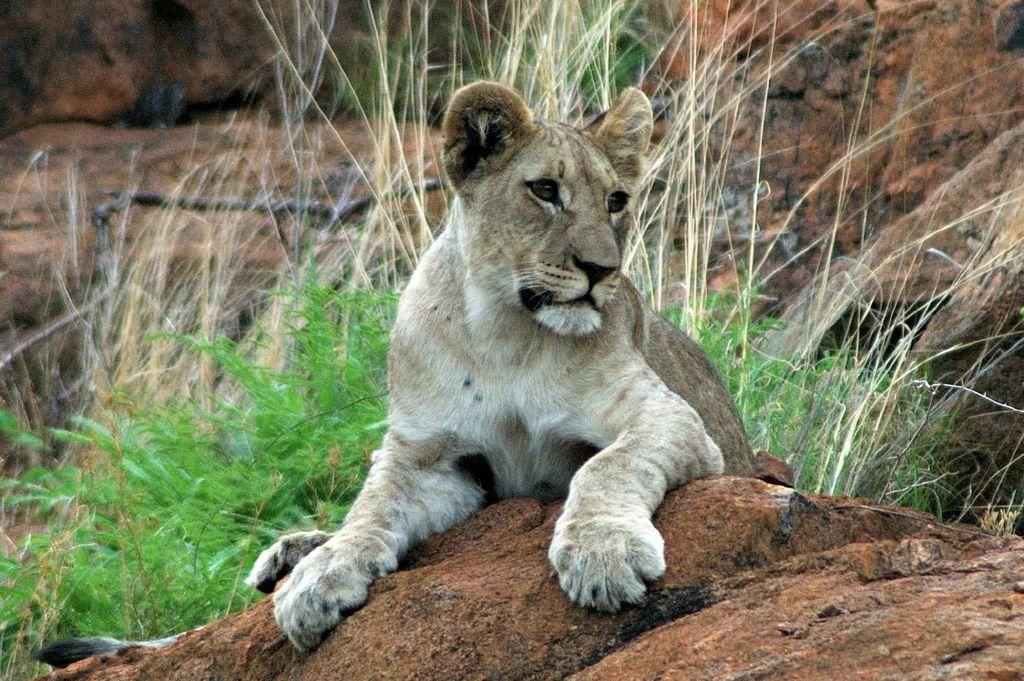What animal is the main subject of the image? There is a lion in the image. Where is the lion located? The lion is on a rock. What type of vegetation is visible behind the lion? There is grass behind the lion. What type of mouth does the lion have in the image? The image does not show the lion's mouth, so it cannot be determined from the image. 